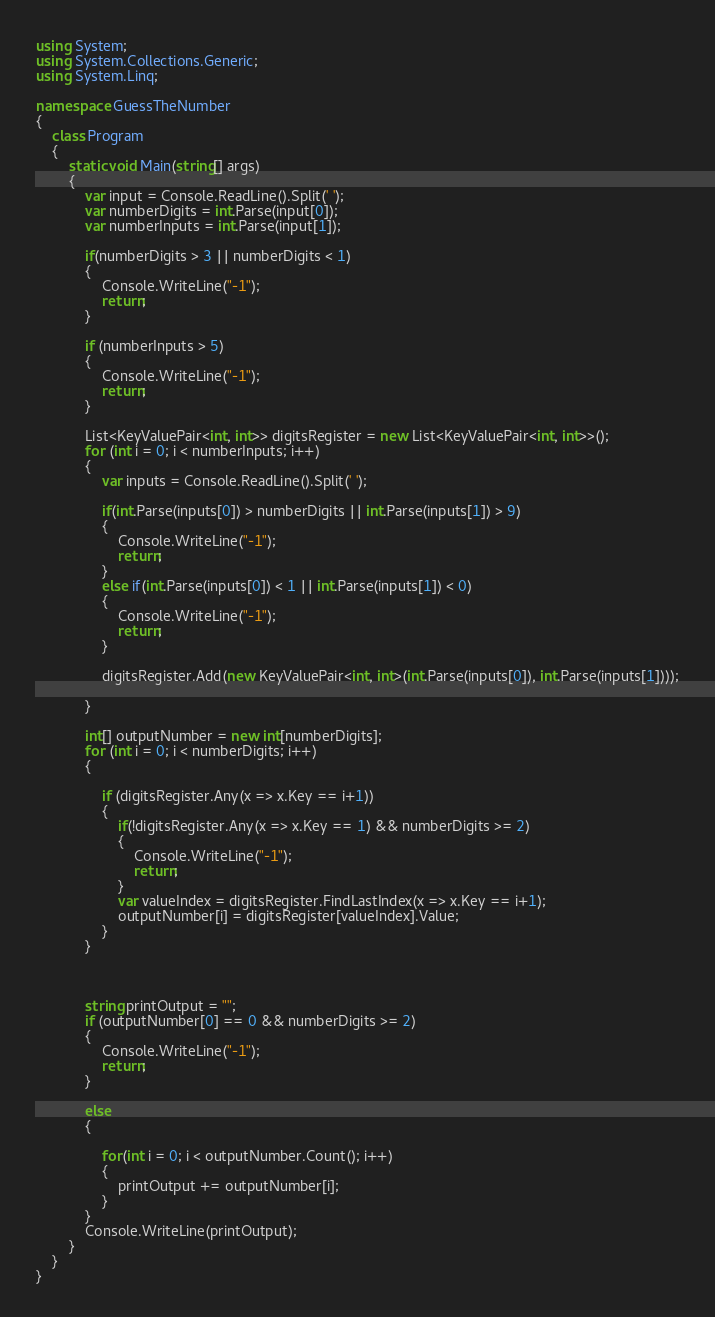Convert code to text. <code><loc_0><loc_0><loc_500><loc_500><_C#_>using System;
using System.Collections.Generic;
using System.Linq;

namespace GuessTheNumber
{
    class Program
    {
        static void Main(string[] args)
        {
            var input = Console.ReadLine().Split(' ');
            var numberDigits = int.Parse(input[0]);
            var numberInputs = int.Parse(input[1]);

            if(numberDigits > 3 || numberDigits < 1)
            {
                Console.WriteLine("-1");
                return;
            }

            if (numberInputs > 5)
            {
                Console.WriteLine("-1");
                return;
            }

            List<KeyValuePair<int, int>> digitsRegister = new List<KeyValuePair<int, int>>();
            for (int i = 0; i < numberInputs; i++)
            {
                var inputs = Console.ReadLine().Split(' ');
                
                if(int.Parse(inputs[0]) > numberDigits || int.Parse(inputs[1]) > 9)
                {
                    Console.WriteLine("-1");
                    return;
                }
                else if(int.Parse(inputs[0]) < 1 || int.Parse(inputs[1]) < 0)
                {
                    Console.WriteLine("-1");
                    return;
                }
                                
                digitsRegister.Add(new KeyValuePair<int, int>(int.Parse(inputs[0]), int.Parse(inputs[1])));

            }

            int[] outputNumber = new int[numberDigits];
            for (int i = 0; i < numberDigits; i++)
            {
                
                if (digitsRegister.Any(x => x.Key == i+1))
                {
                    if(!digitsRegister.Any(x => x.Key == 1) && numberDigits >= 2)
                    {
                        Console.WriteLine("-1");
                        return;
                    }
                    var valueIndex = digitsRegister.FindLastIndex(x => x.Key == i+1);
                    outputNumber[i] = digitsRegister[valueIndex].Value;
                }
            }



            string printOutput = "";
            if (outputNumber[0] == 0 && numberDigits >= 2)
            {
                Console.WriteLine("-1");
                return;
            }

            else
            {
                
                for(int i = 0; i < outputNumber.Count(); i++)
                {
                    printOutput += outputNumber[i];
                }
            }
            Console.WriteLine(printOutput);
        }
    }
}
</code> 